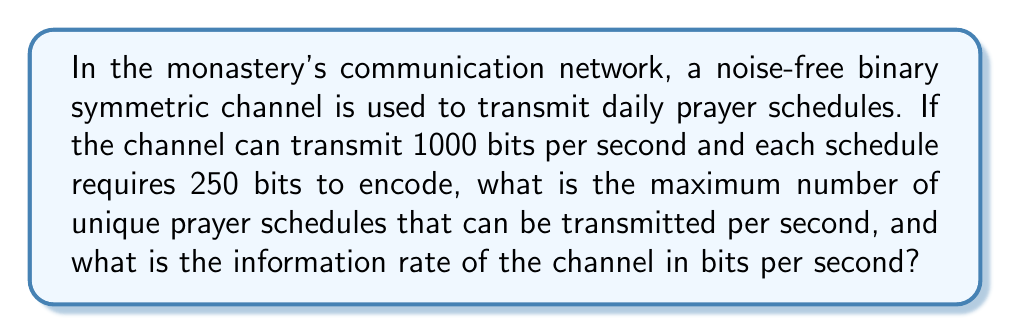Teach me how to tackle this problem. To solve this problem, we need to apply concepts from information theory:

1. Channel capacity:
   The channel can transmit 1000 bits per second.

2. Message length:
   Each prayer schedule requires 250 bits to encode.

3. Number of unique messages per second:
   $$\text{Unique messages} = \frac{\text{Channel capacity}}{\text{Message length}} = \frac{1000 \text{ bits/s}}{250 \text{ bits/message}} = 4 \text{ messages/s}$$

4. Information content:
   For a noise-free binary symmetric channel, the information content of each bit is 1 bit. Therefore, the information rate is equal to the channel capacity.

5. Information rate:
   $$\text{Information rate} = 1000 \text{ bits/s}$$

In information theory, the capacity of a noise-free channel is given by:

$$C = \log_2(M)$$

Where $C$ is the channel capacity in bits per symbol, and $M$ is the number of possible symbols.

In this case, we have a binary channel, so $M = 2$:

$$C = \log_2(2) = 1 \text{ bit/symbol}$$

This confirms that each transmitted bit carries 1 bit of information, and the information rate is equal to the channel capacity.
Answer: The maximum number of unique prayer schedules that can be transmitted per second is 4, and the information rate of the channel is 1000 bits per second. 